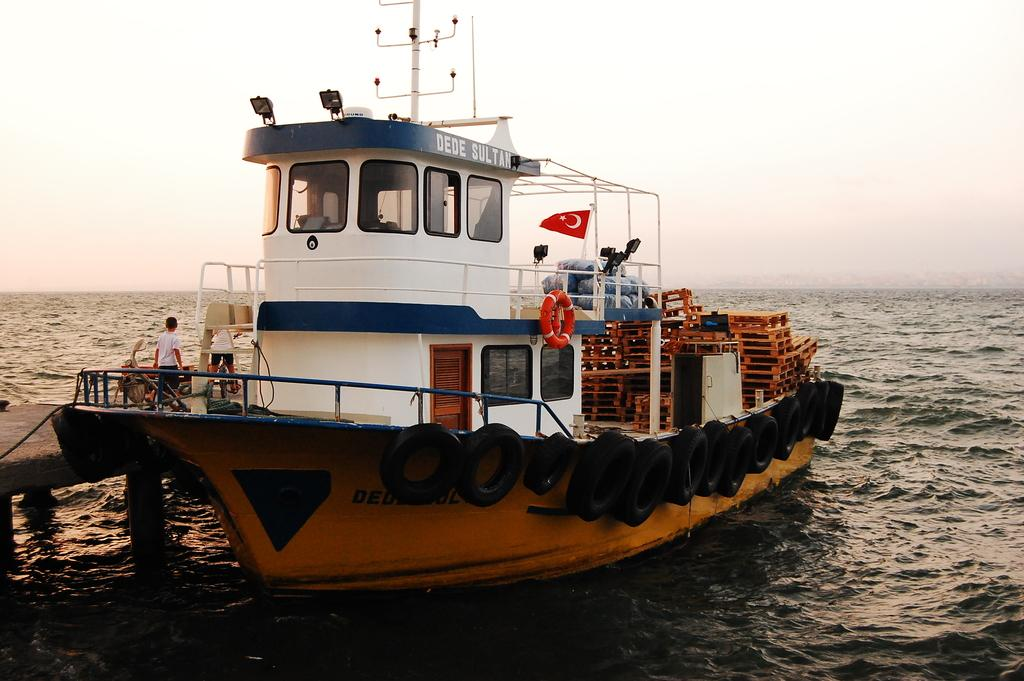What is the main subject in the center of the picture? There is a ship in the center of the picture. What can be seen on the left side of the picture? There is a dock on the left side of the picture. Are there any people visible in the image? Yes, two people are standing on the dock. What is visible in the foreground of the picture? There is water in the foreground of the picture. How would you describe the sky in the image? The sky is clear in the image. What type of meat is being served on the ship in the image? There is no meat visible in the image, as it features a ship, a dock, and two people standing on the dock. 